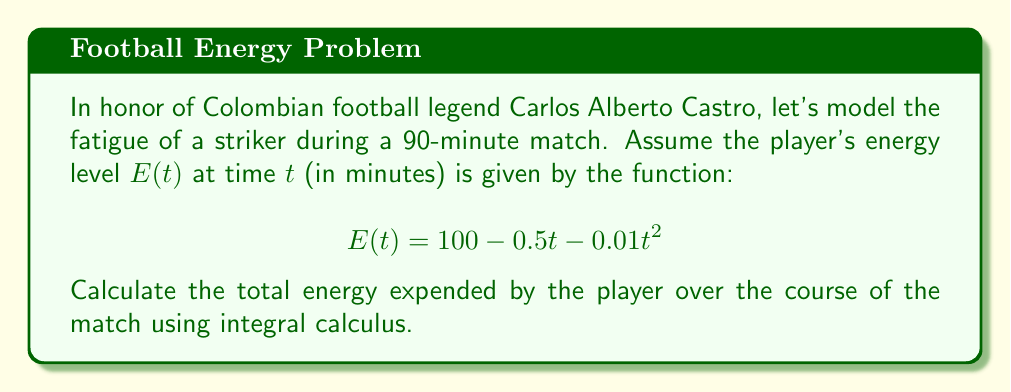What is the answer to this math problem? To solve this problem, we need to follow these steps:

1) The energy expended is the difference between the initial energy and the energy at any given time. Therefore, we need to integrate the rate of energy change over time.

2) The rate of energy change is the negative of the derivative of $E(t)$:

   $$\frac{dE}{dt} = -0.5 - 0.02t$$

3) To find the total energy expended, we integrate this rate over the duration of the match (0 to 90 minutes):

   $$\text{Total Energy Expended} = \int_0^{90} (-\frac{dE}{dt}) dt = \int_0^{90} (0.5 + 0.02t) dt$$

4) Let's solve this integral:

   $$\begin{align*}
   \int_0^{90} (0.5 + 0.02t) dt &= [0.5t + 0.01t^2]_0^{90} \\
   &= (0.5 \cdot 90 + 0.01 \cdot 90^2) - (0.5 \cdot 0 + 0.01 \cdot 0^2) \\
   &= 45 + 81 - 0 \\
   &= 126
   \end{align*}$$

5) Therefore, the total energy expended over the 90-minute match is 126 energy units.
Answer: 126 energy units 